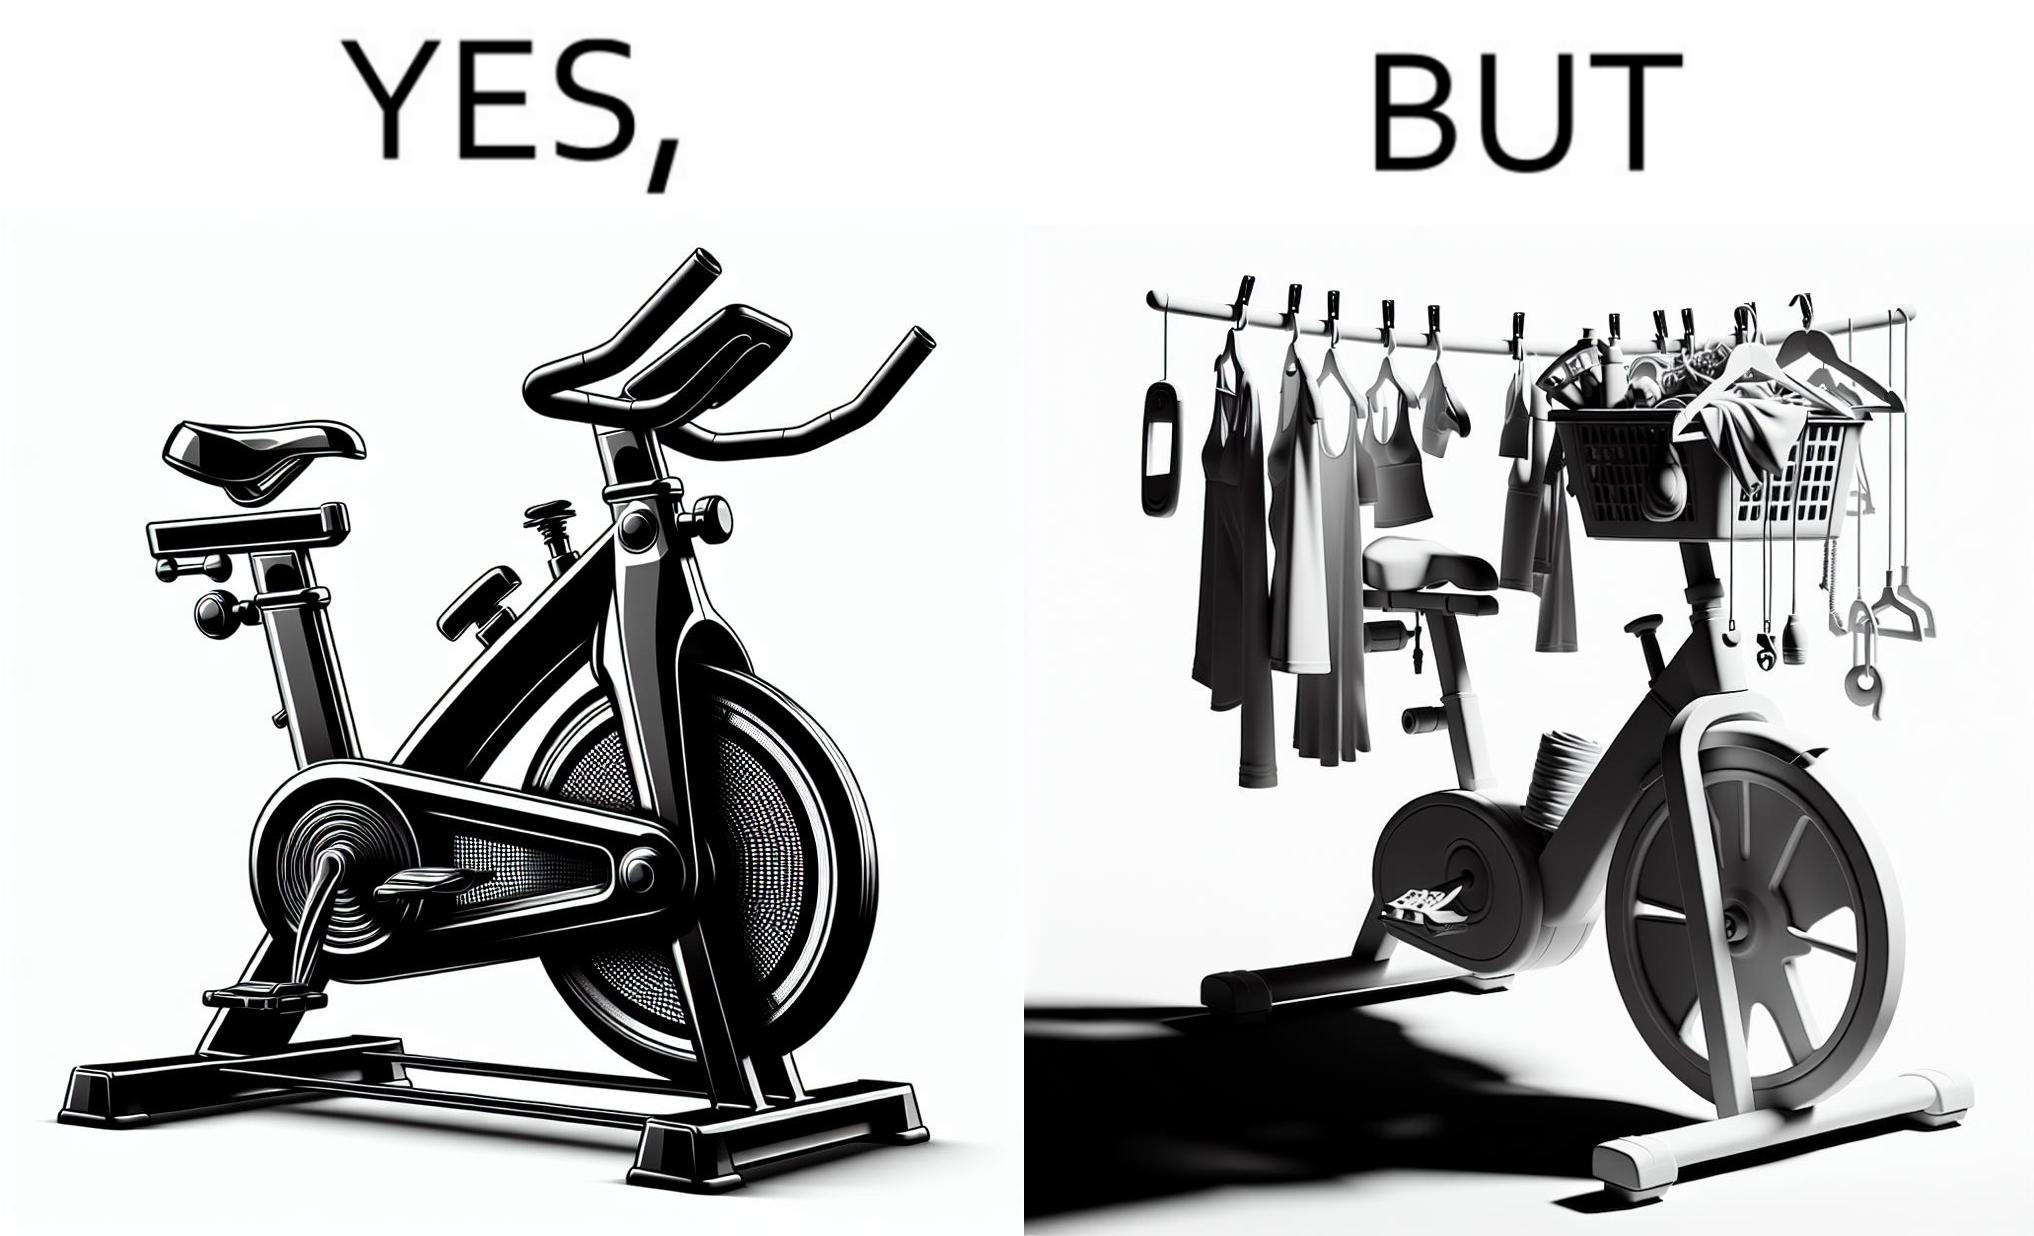Is this a satirical image? Yes, this image is satirical. 